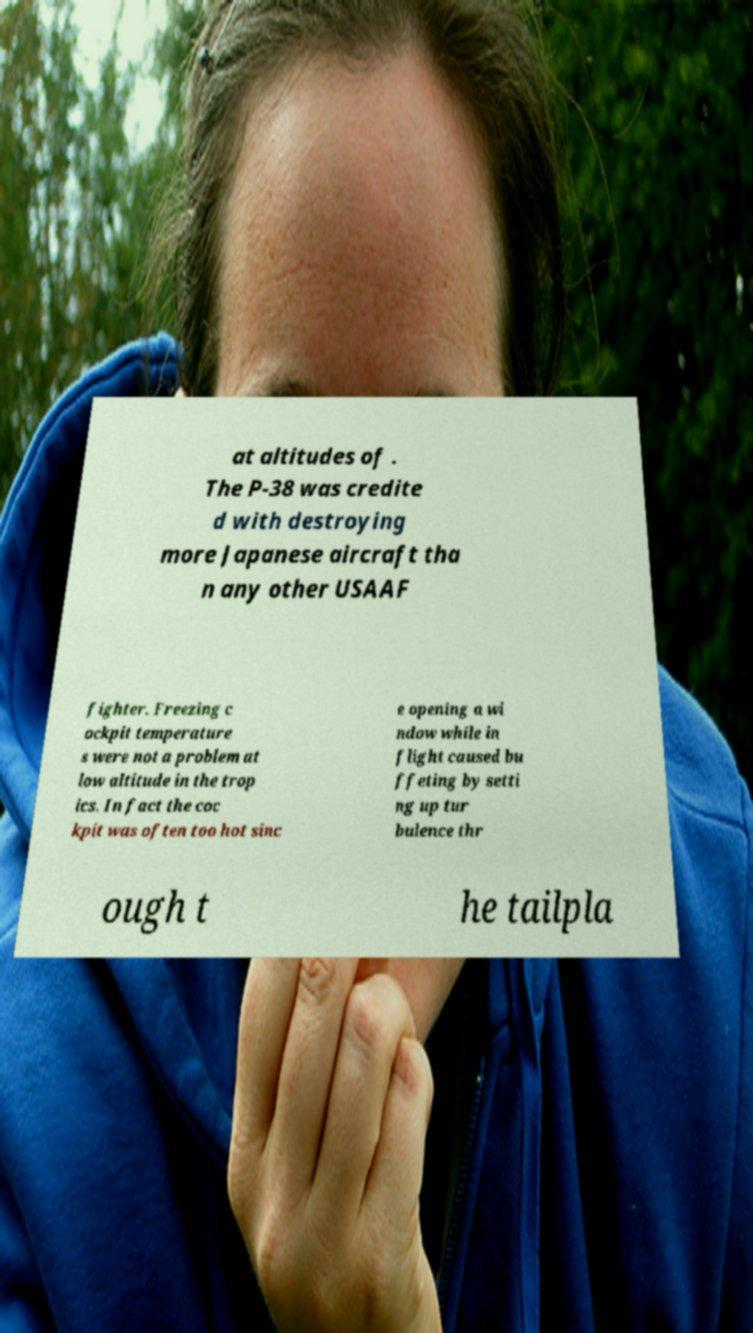Can you read and provide the text displayed in the image?This photo seems to have some interesting text. Can you extract and type it out for me? at altitudes of . The P-38 was credite d with destroying more Japanese aircraft tha n any other USAAF fighter. Freezing c ockpit temperature s were not a problem at low altitude in the trop ics. In fact the coc kpit was often too hot sinc e opening a wi ndow while in flight caused bu ffeting by setti ng up tur bulence thr ough t he tailpla 